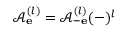Convert formula to latex. <formula><loc_0><loc_0><loc_500><loc_500>\mathcal { A } _ { e } ^ { ( l ) } = \mathcal { A } _ { - e } ^ { ( l ) } ( - ) ^ { l }</formula> 